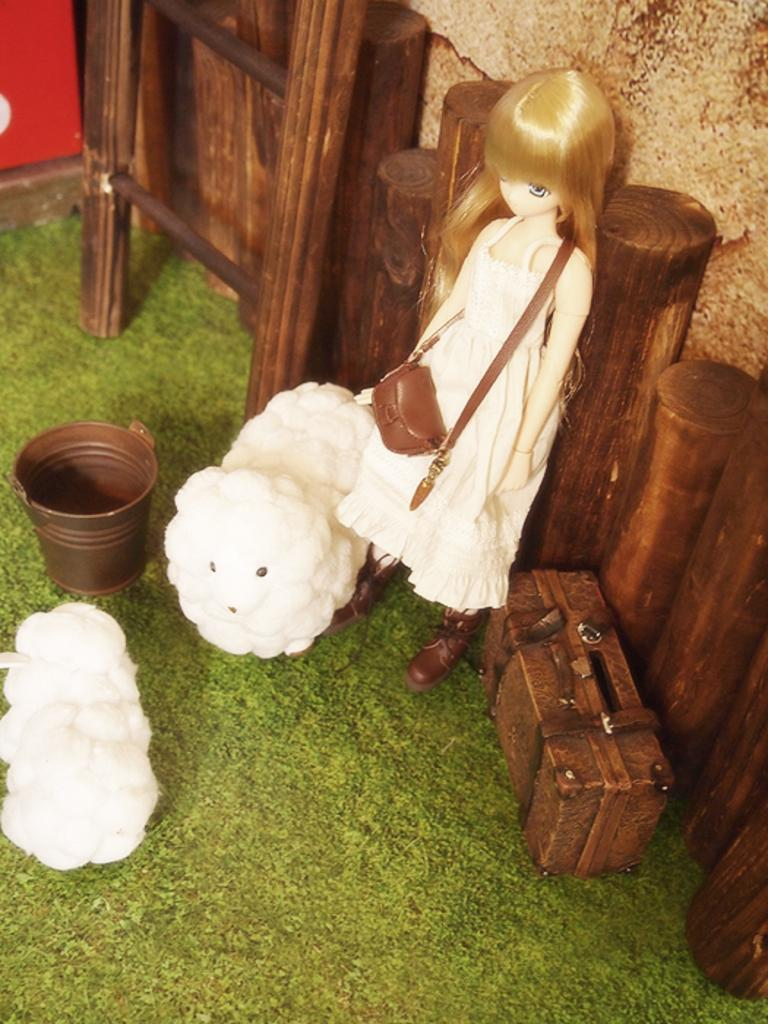What type of objects can be seen in the image? There are toys in the image, including a doll and toy sheep. What else is present in the image? There is a toy bucket and a suitcase in the image. What is the ground made of in the image? The ground is covered with grass in the image. What type of popcorn is being served in the image? There is no popcorn present in the image. Can you describe the chair that the donkey is sitting on in the image? There is no donkey or chair present in the image. 